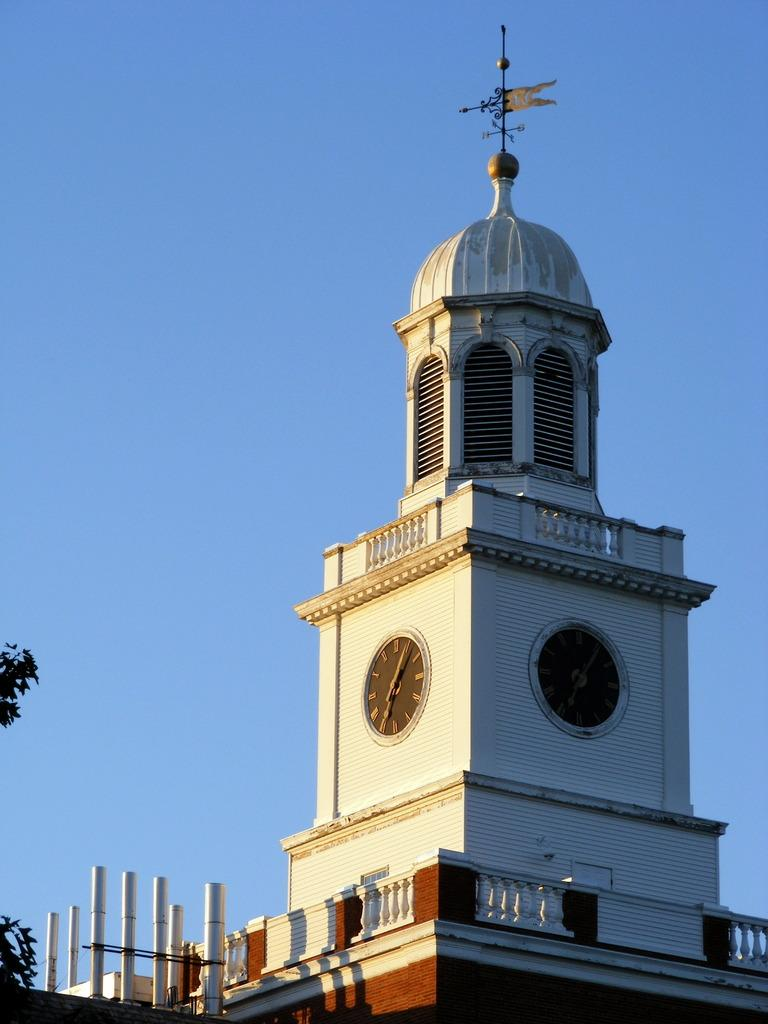What structure is the main subject of the image? There is a building in the image. Are there any additional features attached to the building? Yes, there are two blocks attached to the building. What type of vegetation can be seen in the background of the image? Plants are visible in the background of the image. What color is the sky in the image? The sky is blue in color. Can you see any stars on the board in the image? There is no board or stars present in the image. 